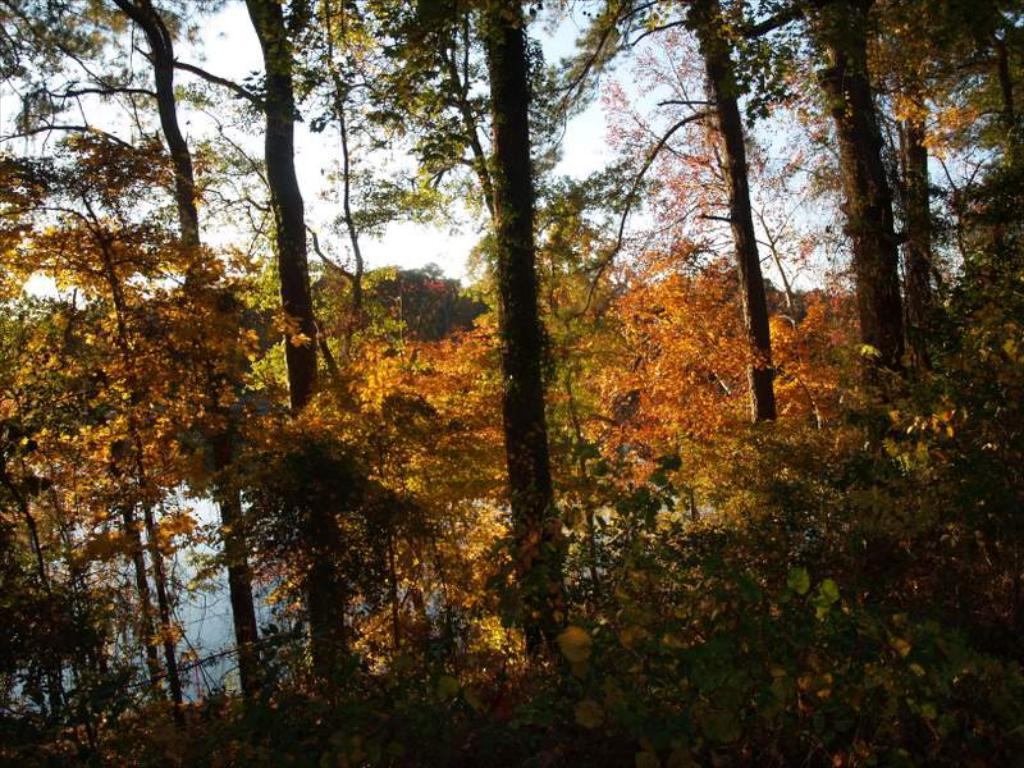What type of vegetation can be seen in the image? There are many trees, plants, and grass present in the image. What natural elements can be seen in the image? Water, sky, and clouds are visible in the image. What specific features of the trees can be observed in the image? Leaves are visible on the trees in the image. What type of nerve can be seen in the image? There is no nerve present in the image; it features natural elements such as trees, water, and sky. 